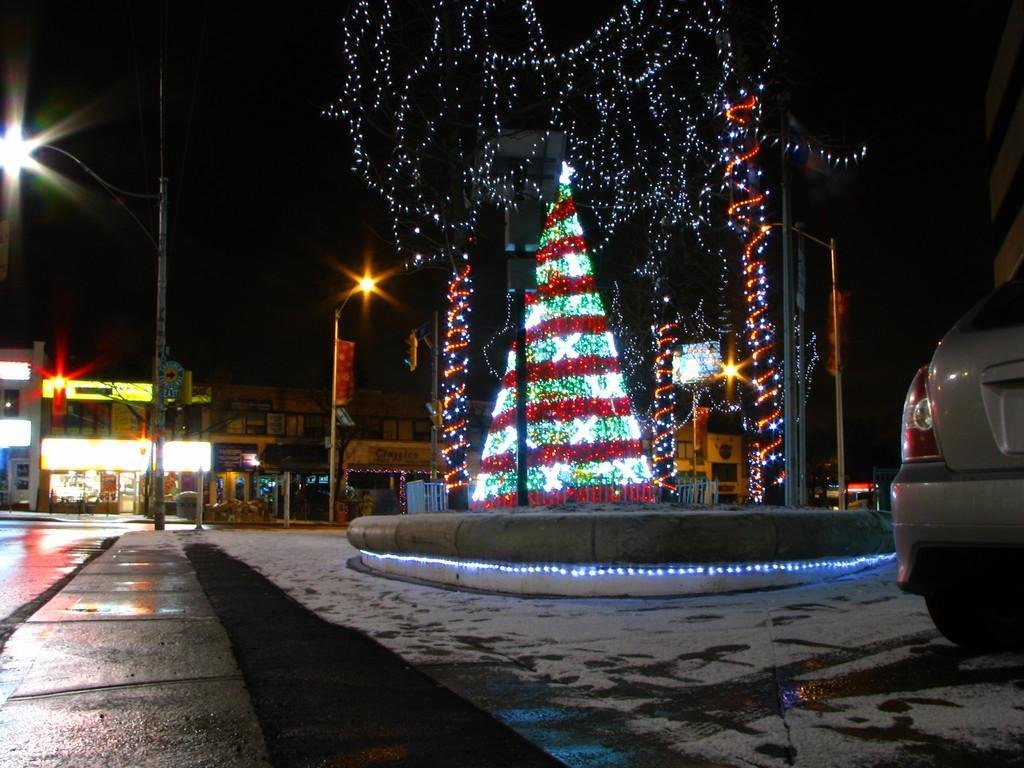How would you summarize this image in a sentence or two? In this image I see the path and I see a car over here and I see the decoration of lights over here. In the background I see the buildings and I see the streetlights and I see the sky which is dark. 